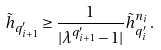<formula> <loc_0><loc_0><loc_500><loc_500>\tilde { h } _ { q _ { i + 1 } ^ { \prime } } \geq \frac { 1 } { | \lambda ^ { q _ { i + 1 } ^ { \prime } } - 1 | } \tilde { h } _ { q _ { i } ^ { \prime } } ^ { n _ { i } } \, .</formula> 